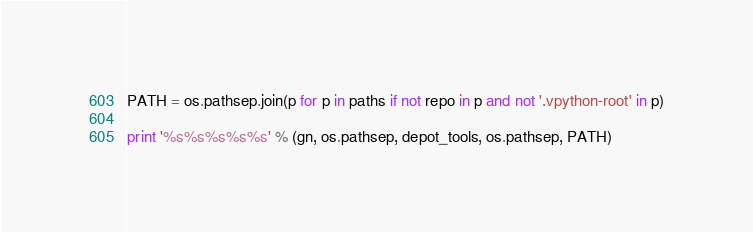Convert code to text. <code><loc_0><loc_0><loc_500><loc_500><_Python_>
PATH = os.pathsep.join(p for p in paths if not repo in p and not '.vpython-root' in p)

print '%s%s%s%s%s' % (gn, os.pathsep, depot_tools, os.pathsep, PATH)
</code> 